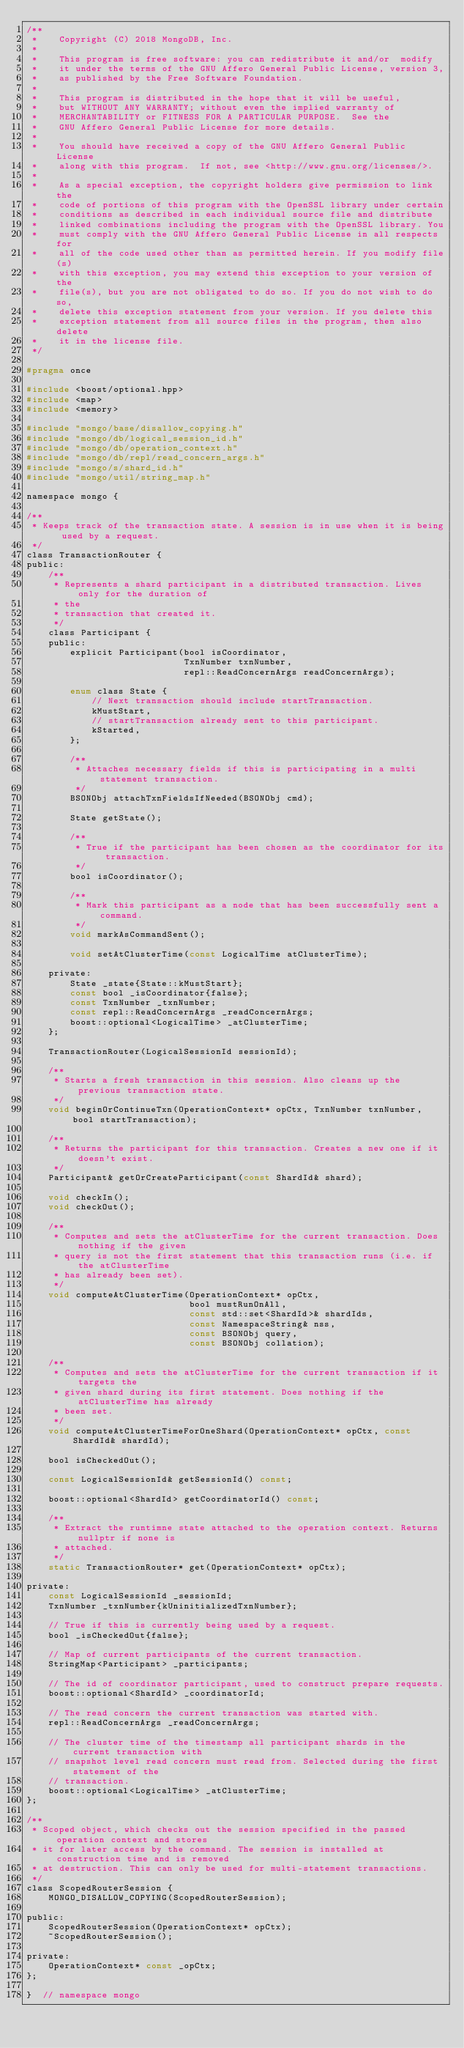<code> <loc_0><loc_0><loc_500><loc_500><_C_>/**
 *    Copyright (C) 2018 MongoDB, Inc.
 *
 *    This program is free software: you can redistribute it and/or  modify
 *    it under the terms of the GNU Affero General Public License, version 3,
 *    as published by the Free Software Foundation.
 *
 *    This program is distributed in the hope that it will be useful,
 *    but WITHOUT ANY WARRANTY; without even the implied warranty of
 *    MERCHANTABILITY or FITNESS FOR A PARTICULAR PURPOSE.  See the
 *    GNU Affero General Public License for more details.
 *
 *    You should have received a copy of the GNU Affero General Public License
 *    along with this program.  If not, see <http://www.gnu.org/licenses/>.
 *
 *    As a special exception, the copyright holders give permission to link the
 *    code of portions of this program with the OpenSSL library under certain
 *    conditions as described in each individual source file and distribute
 *    linked combinations including the program with the OpenSSL library. You
 *    must comply with the GNU Affero General Public License in all respects for
 *    all of the code used other than as permitted herein. If you modify file(s)
 *    with this exception, you may extend this exception to your version of the
 *    file(s), but you are not obligated to do so. If you do not wish to do so,
 *    delete this exception statement from your version. If you delete this
 *    exception statement from all source files in the program, then also delete
 *    it in the license file.
 */

#pragma once

#include <boost/optional.hpp>
#include <map>
#include <memory>

#include "mongo/base/disallow_copying.h"
#include "mongo/db/logical_session_id.h"
#include "mongo/db/operation_context.h"
#include "mongo/db/repl/read_concern_args.h"
#include "mongo/s/shard_id.h"
#include "mongo/util/string_map.h"

namespace mongo {

/**
 * Keeps track of the transaction state. A session is in use when it is being used by a request.
 */
class TransactionRouter {
public:
    /**
     * Represents a shard participant in a distributed transaction. Lives only for the duration of
     * the
     * transaction that created it.
     */
    class Participant {
    public:
        explicit Participant(bool isCoordinator,
                             TxnNumber txnNumber,
                             repl::ReadConcernArgs readConcernArgs);

        enum class State {
            // Next transaction should include startTransaction.
            kMustStart,
            // startTransaction already sent to this participant.
            kStarted,
        };

        /**
         * Attaches necessary fields if this is participating in a multi statement transaction.
         */
        BSONObj attachTxnFieldsIfNeeded(BSONObj cmd);

        State getState();

        /**
         * True if the participant has been chosen as the coordinator for its transaction.
         */
        bool isCoordinator();

        /**
         * Mark this participant as a node that has been successfully sent a command.
         */
        void markAsCommandSent();

        void setAtClusterTime(const LogicalTime atClusterTime);

    private:
        State _state{State::kMustStart};
        const bool _isCoordinator{false};
        const TxnNumber _txnNumber;
        const repl::ReadConcernArgs _readConcernArgs;
        boost::optional<LogicalTime> _atClusterTime;
    };

    TransactionRouter(LogicalSessionId sessionId);

    /**
     * Starts a fresh transaction in this session. Also cleans up the previous transaction state.
     */
    void beginOrContinueTxn(OperationContext* opCtx, TxnNumber txnNumber, bool startTransaction);

    /**
     * Returns the participant for this transaction. Creates a new one if it doesn't exist.
     */
    Participant& getOrCreateParticipant(const ShardId& shard);

    void checkIn();
    void checkOut();

    /**
     * Computes and sets the atClusterTime for the current transaction. Does nothing if the given
     * query is not the first statement that this transaction runs (i.e. if the atClusterTime
     * has already been set).
     */
    void computeAtClusterTime(OperationContext* opCtx,
                              bool mustRunOnAll,
                              const std::set<ShardId>& shardIds,
                              const NamespaceString& nss,
                              const BSONObj query,
                              const BSONObj collation);

    /**
     * Computes and sets the atClusterTime for the current transaction if it targets the
     * given shard during its first statement. Does nothing if the atClusterTime has already
     * been set.
     */
    void computeAtClusterTimeForOneShard(OperationContext* opCtx, const ShardId& shardId);

    bool isCheckedOut();

    const LogicalSessionId& getSessionId() const;

    boost::optional<ShardId> getCoordinatorId() const;

    /**
     * Extract the runtimne state attached to the operation context. Returns nullptr if none is
     * attached.
     */
    static TransactionRouter* get(OperationContext* opCtx);

private:
    const LogicalSessionId _sessionId;
    TxnNumber _txnNumber{kUninitializedTxnNumber};

    // True if this is currently being used by a request.
    bool _isCheckedOut{false};

    // Map of current participants of the current transaction.
    StringMap<Participant> _participants;

    // The id of coordinator participant, used to construct prepare requests.
    boost::optional<ShardId> _coordinatorId;

    // The read concern the current transaction was started with.
    repl::ReadConcernArgs _readConcernArgs;

    // The cluster time of the timestamp all participant shards in the current transaction with
    // snapshot level read concern must read from. Selected during the first statement of the
    // transaction.
    boost::optional<LogicalTime> _atClusterTime;
};

/**
 * Scoped object, which checks out the session specified in the passed operation context and stores
 * it for later access by the command. The session is installed at construction time and is removed
 * at destruction. This can only be used for multi-statement transactions.
 */
class ScopedRouterSession {
    MONGO_DISALLOW_COPYING(ScopedRouterSession);

public:
    ScopedRouterSession(OperationContext* opCtx);
    ~ScopedRouterSession();

private:
    OperationContext* const _opCtx;
};

}  // namespace mongo
</code> 